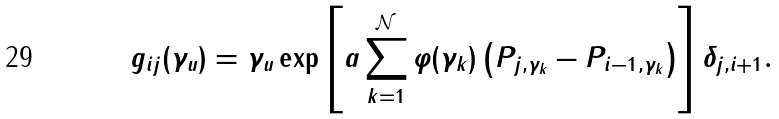<formula> <loc_0><loc_0><loc_500><loc_500>g _ { i j } ( \gamma _ { u } ) = \gamma _ { u } \exp \left [ a \sum _ { k = 1 } ^ { \mathcal { N } } \varphi ( \gamma _ { k } ) \left ( P _ { j , \gamma _ { k } } - P _ { i - 1 , \gamma _ { k } } \right ) \right ] \delta _ { j , i + 1 } .</formula> 